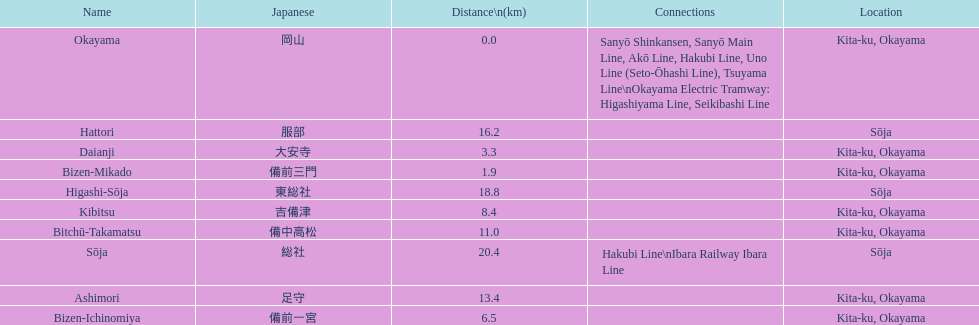Hattori and kibitsu: which of the two has a greater distance? Hattori. 